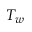Convert formula to latex. <formula><loc_0><loc_0><loc_500><loc_500>T _ { w }</formula> 